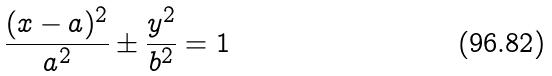<formula> <loc_0><loc_0><loc_500><loc_500>\frac { ( x - a ) ^ { 2 } } { a ^ { 2 } } \pm \frac { y ^ { 2 } } { b ^ { 2 } } = 1</formula> 